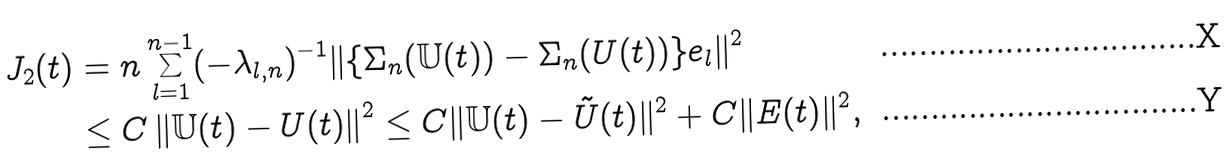<formula> <loc_0><loc_0><loc_500><loc_500>J _ { 2 } ( t ) & = n \sum _ { l = 1 } ^ { n - 1 } ( - \lambda _ { l , n } ) ^ { - 1 } \| \{ \Sigma _ { n } ( \mathbb { U } ( t ) ) - \Sigma _ { n } ( U ( t ) ) \} e _ { l } \| ^ { 2 } \\ & \leq C \left \| \mathbb { U } ( t ) - U ( t ) \right \| ^ { 2 } \leq C \| \mathbb { U } ( t ) - \tilde { U } ( t ) \| ^ { 2 } + C \| E ( t ) \| ^ { 2 } ,</formula> 